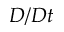Convert formula to latex. <formula><loc_0><loc_0><loc_500><loc_500>D / D t</formula> 